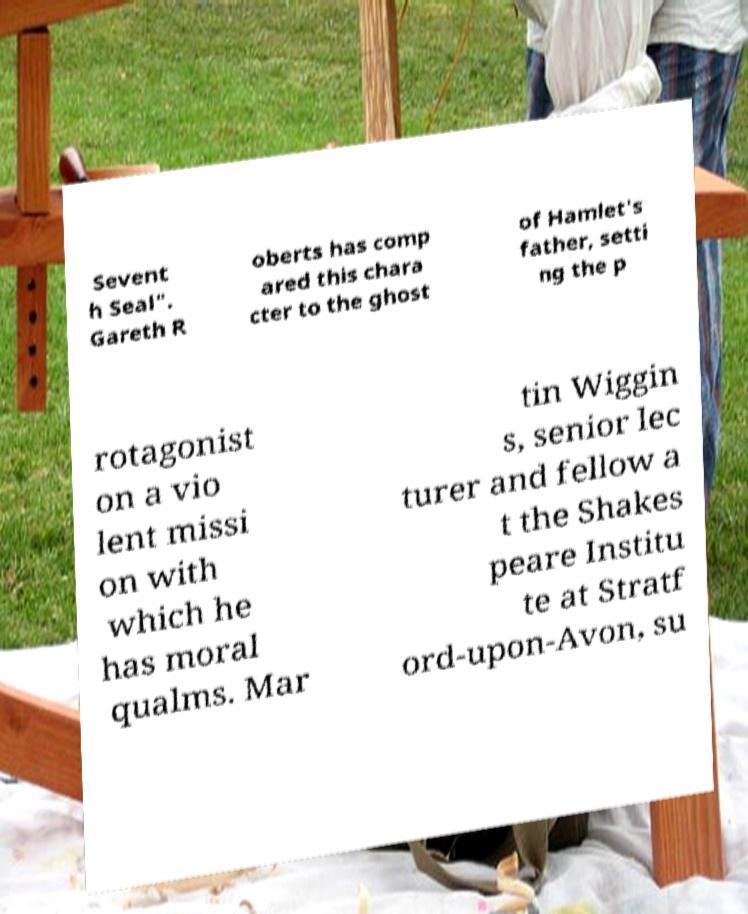Can you accurately transcribe the text from the provided image for me? Sevent h Seal". Gareth R oberts has comp ared this chara cter to the ghost of Hamlet's father, setti ng the p rotagonist on a vio lent missi on with which he has moral qualms. Mar tin Wiggin s, senior lec turer and fellow a t the Shakes peare Institu te at Stratf ord-upon-Avon, su 